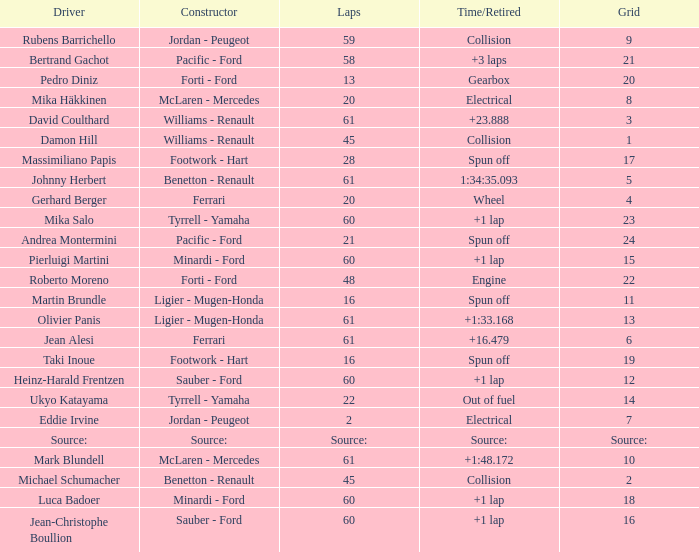What's the time/retired for constructor source:? Source:. 